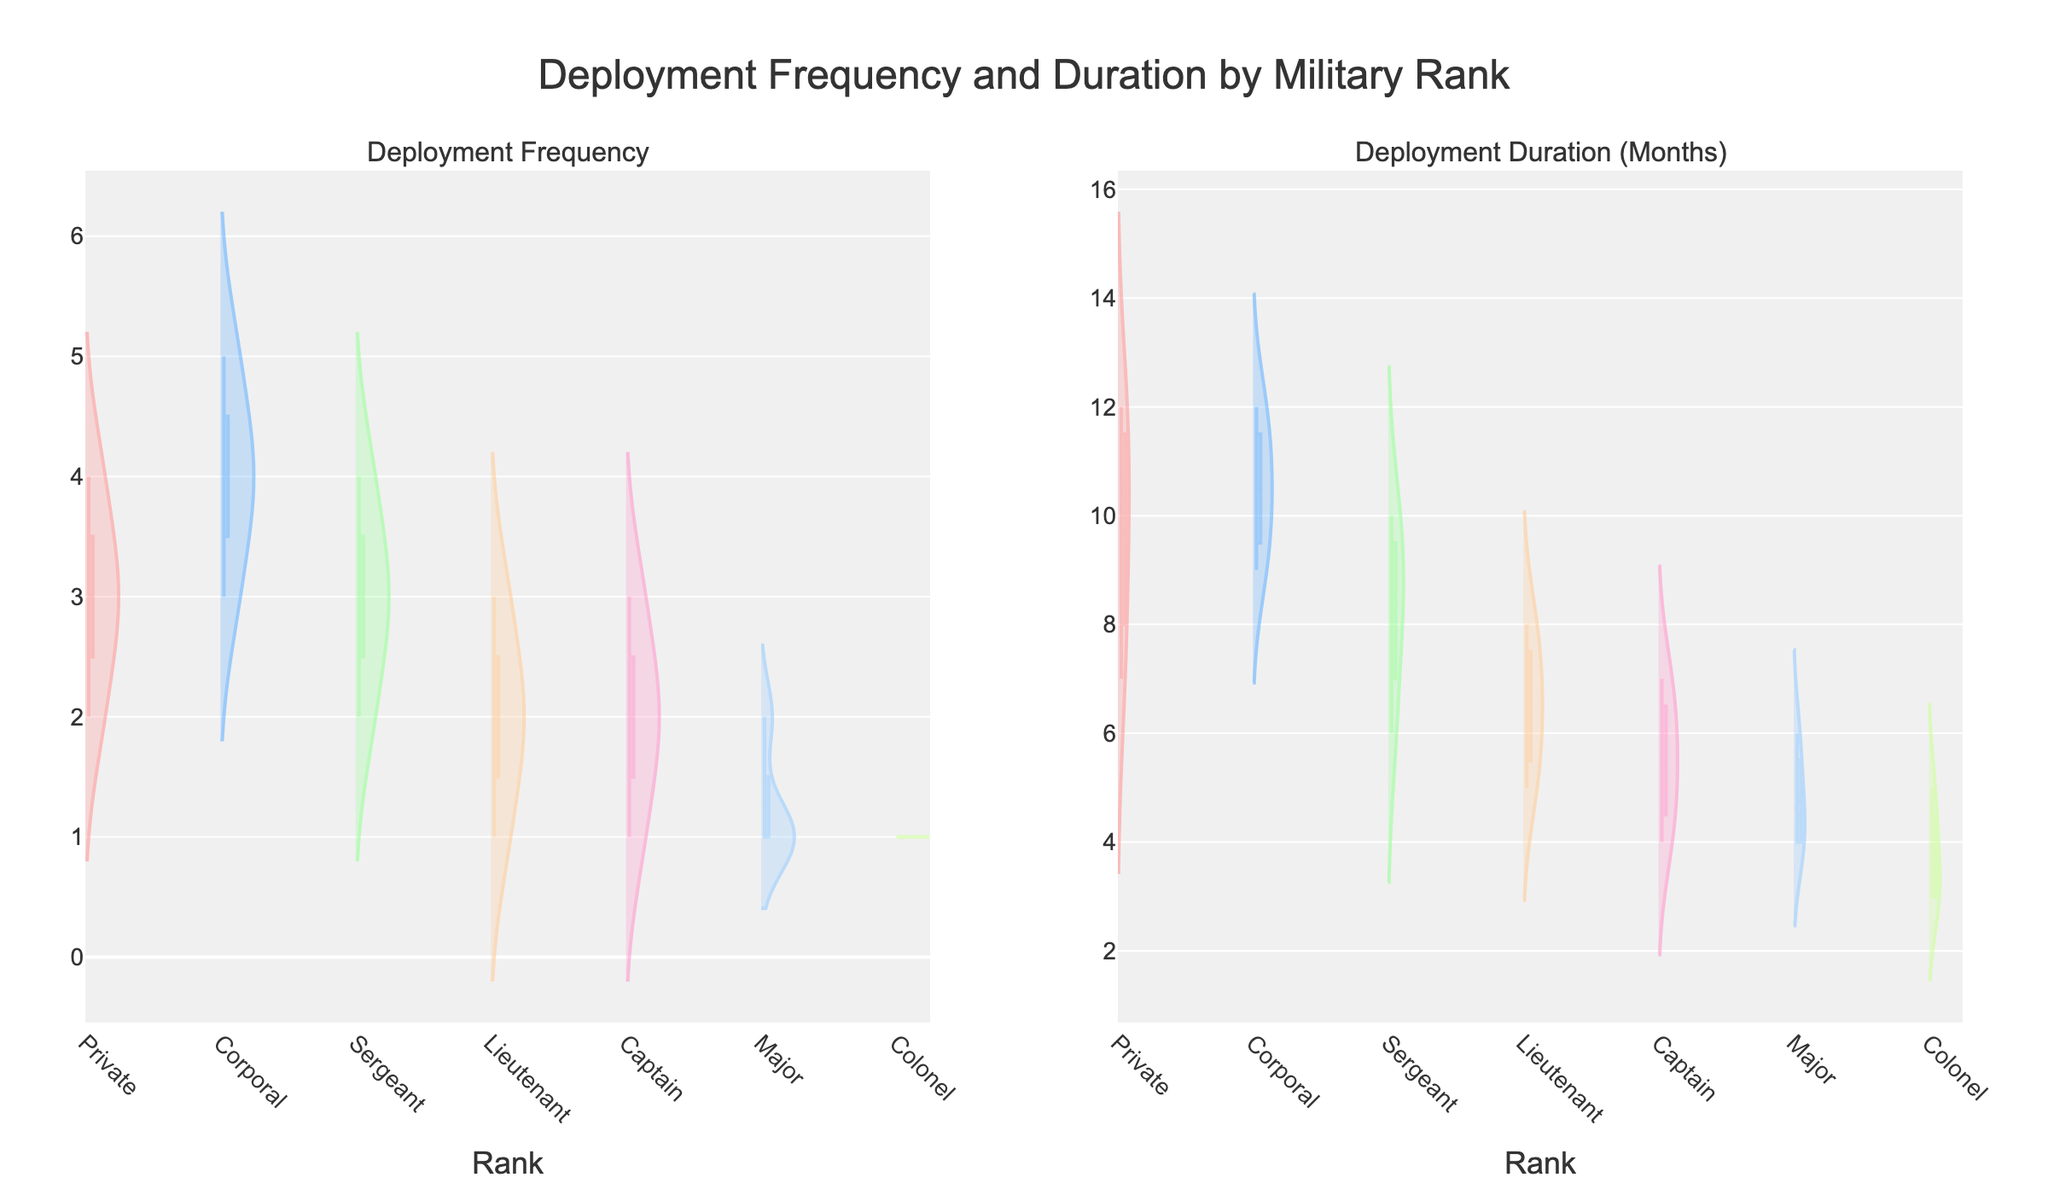How many ranks are represented in the figure? The figure showcases deployment data for different ranks in the military. By counting the unique ranks displayed, we determine there are six ranks represented.
Answer: Six Which rank has the highest median deployment frequency? To determine this, locate the median line within each violin plot for deployment frequency. The "Corporal" rank has the highest median, as its median line is positioned the most upwards relative to the y-axis.
Answer: Corporal What is the range of deployment durations for Privates? Examine the violin plot for Privates under deployment duration. The range extends from the minimum to the maximum data points. This spans from 7 months to 12 months.
Answer: 5 months How does deployment duration for Captains compare to that of Majors? Observe the deployment duration violin plots for both Captains and Majors. Captains have a slightly higher median value, but the general spread of deployment duration is quite similar. Both ranks have overlapping interquartile ranges.
Answer: Similar spread, captains slightly higher median What can you infer about Colonels' deployment frequency? Colonels consistently show a deployment frequency of one, as indicated by the very narrow and tall violin plot matching the y-axis at value one. This suggests little to no variability.
Answer: Consistently one Which rank shows the greatest variability in deployment duration? Variability is indicated by the width and spread of the violin plot. Corporals display the widest and most spread-out violin plot for deployment duration, suggesting high variability.
Answer: Corporal Can you identify any rank with consistent deployment frequency and duration? Colonel stands out due to identical violin plots for both deployment frequency and duration, indicating a consistent pattern without variation.
Answer: Colonel How does the average deployment frequency for Lieutenants compare to Privates? To compare, visually estimate where the mass of the data points lies in the violin plots. Lieutenants seem to have a lower average frequency than Privates, indicated by a downward shift in the median and concentration of data points.
Answer: Lower What trend can be observed as rank increases regarding deployment frequency? Sequentially examining the violin plots, a clear trend emerges where lower ranks such as Privates and Corporals have higher frequencies compared to higher ranks like Colonels, suggesting higher ranks deploy less frequently.
Answer: Higher ranks deploy less frequently Which rank has the broadest interquartile range for deployment duration? The interquartile range is visible in the more opaque, thicker central part of the violin plot. Corporals have the broadest interquartile range, indicating greater variability within middle 50% of the data.
Answer: Corporal 